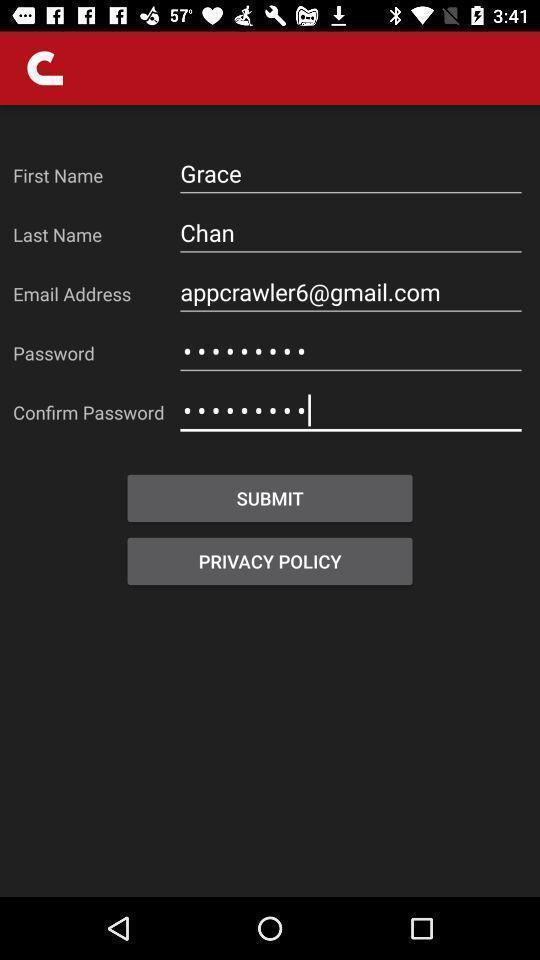Give me a narrative description of this picture. Sign in page. 